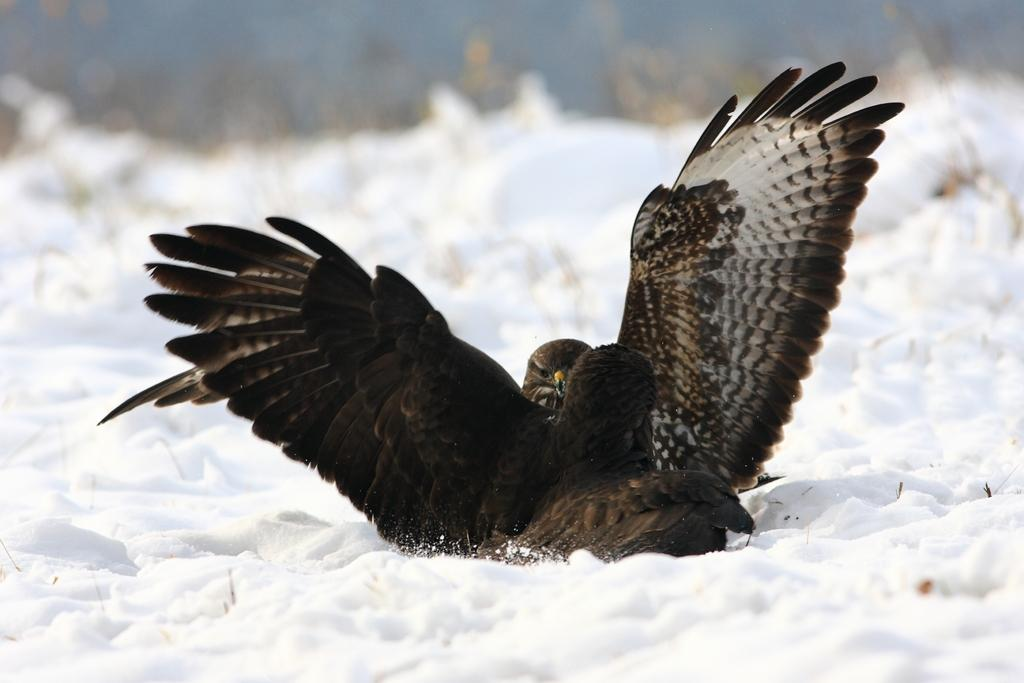What type of animals can be seen in the image? Birds can be seen in the image. Where are the birds situated in the image? The birds are on the snow. Can you describe the background of the image? The background of the image is blurred. What type of tax can be seen being paid by the birds in the image? There is no tax being paid by the birds in the image; it is a natural scene featuring birds on the snow. 